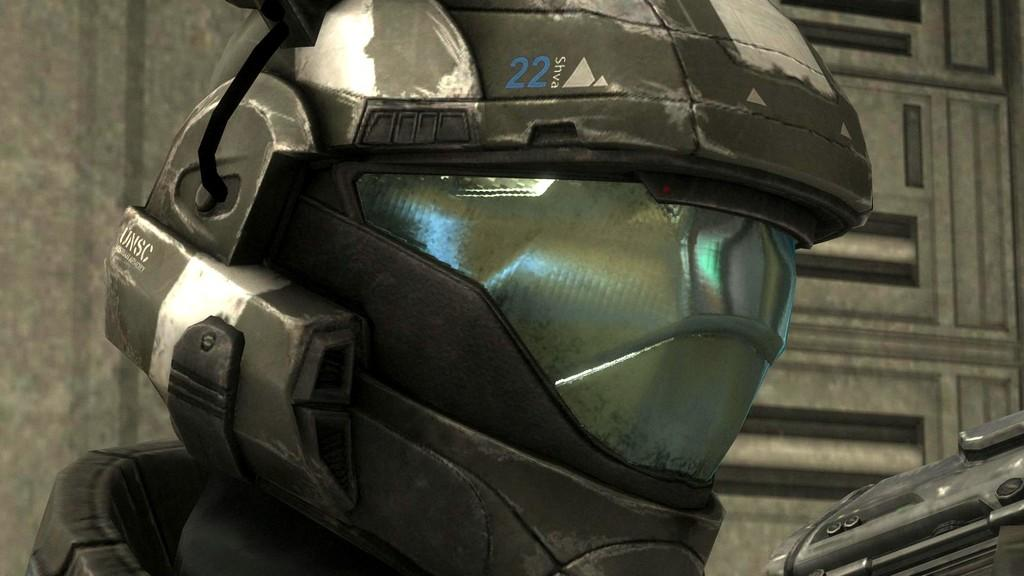What is the main subject of the image? There is a person in the image. What is the person wearing on their head? The person is wearing a helmet. What can be seen behind the person in the image? There is a wall-like structure behind the person. What type of bomb can be seen in the image? There is no bomb present in the image. What kind of watch is the person wearing in the image? The image does not show the person wearing a watch. 